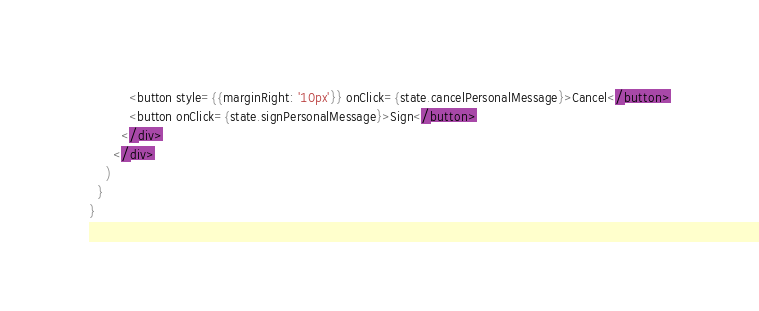Convert code to text. <code><loc_0><loc_0><loc_500><loc_500><_JavaScript_>          <button style={{marginRight: '10px'}} onClick={state.cancelPersonalMessage}>Cancel</button>
          <button onClick={state.signPersonalMessage}>Sign</button>
        </div>
      </div>
    )
  }
}
</code> 